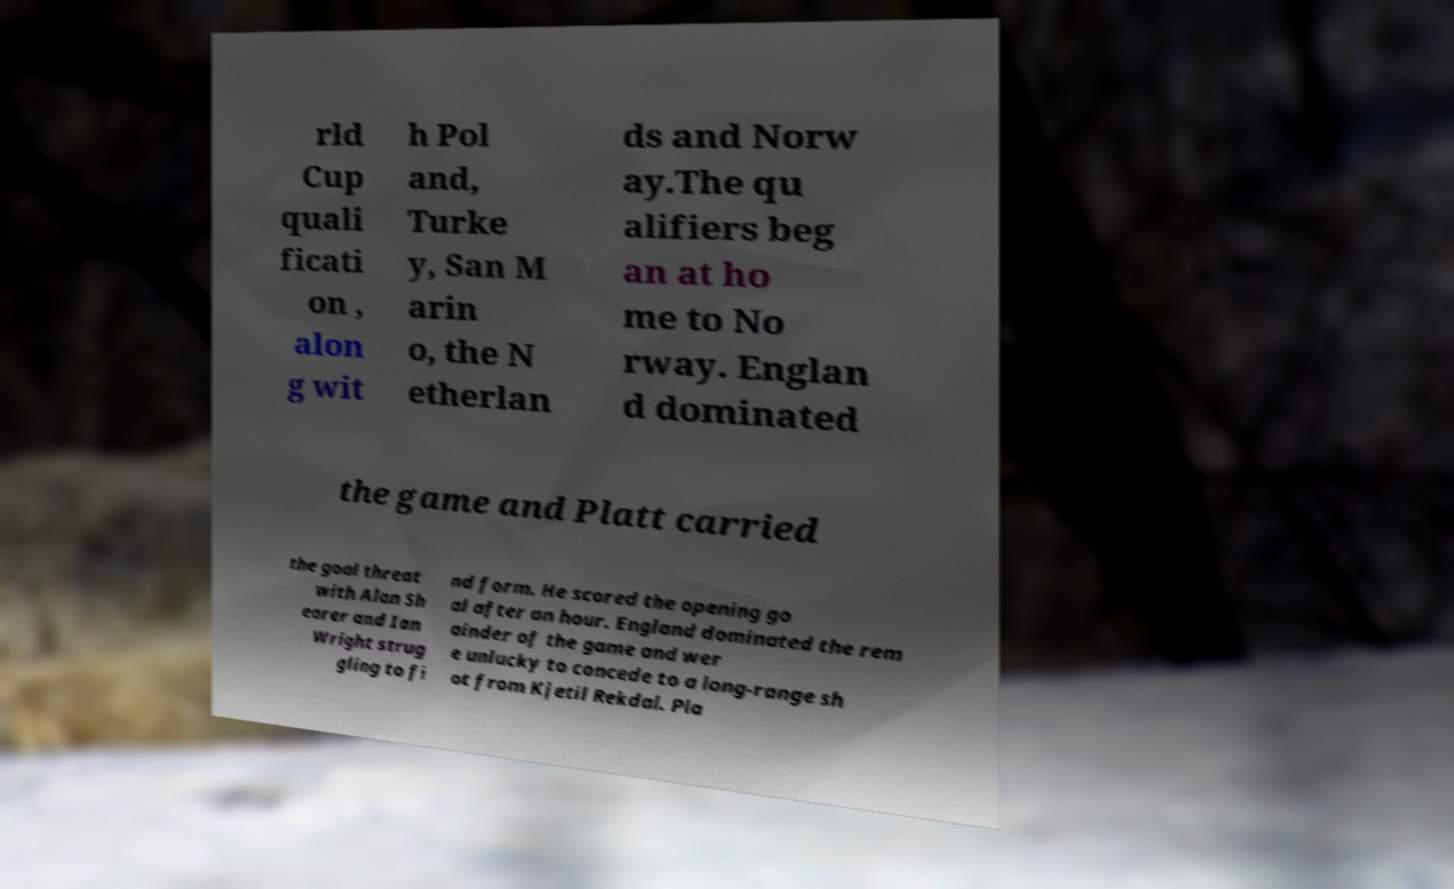There's text embedded in this image that I need extracted. Can you transcribe it verbatim? rld Cup quali ficati on , alon g wit h Pol and, Turke y, San M arin o, the N etherlan ds and Norw ay.The qu alifiers beg an at ho me to No rway. Englan d dominated the game and Platt carried the goal threat with Alan Sh earer and Ian Wright strug gling to fi nd form. He scored the opening go al after an hour. England dominated the rem ainder of the game and wer e unlucky to concede to a long-range sh ot from Kjetil Rekdal. Pla 